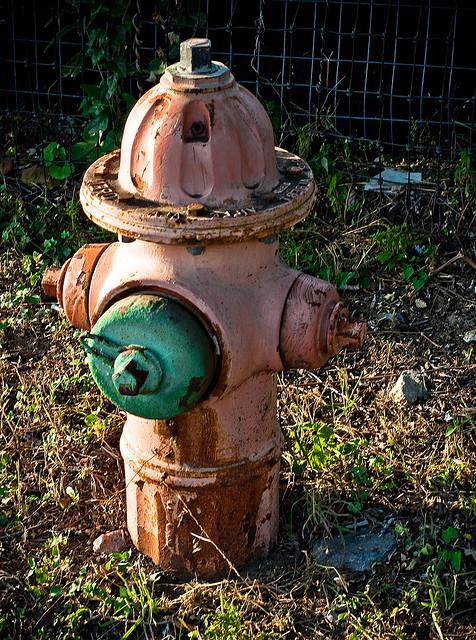Are there chains on the fire hydrant?
Answer briefly. No. What chemical process caused the discoloration?
Write a very short answer. Rust. What is the fence made of in the background?
Keep it brief. Metal. Is the fire hydrant lonely?
Write a very short answer. No. Is the fire hydrant rusted?
Answer briefly. Yes. What color is the structure?
Be succinct. Pink. 